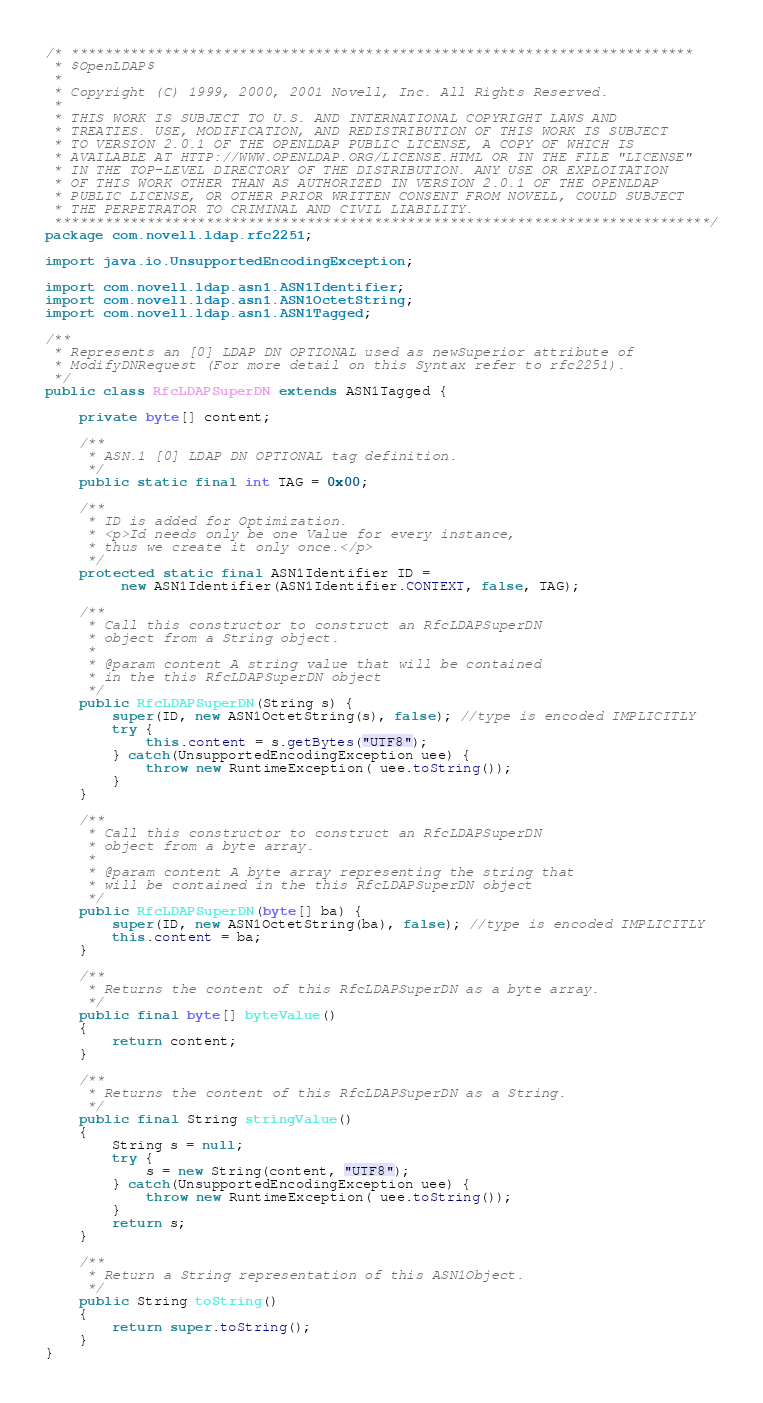<code> <loc_0><loc_0><loc_500><loc_500><_Java_>/* **************************************************************************
 * $OpenLDAP$
 *
 * Copyright (C) 1999, 2000, 2001 Novell, Inc. All Rights Reserved.
 *
 * THIS WORK IS SUBJECT TO U.S. AND INTERNATIONAL COPYRIGHT LAWS AND
 * TREATIES. USE, MODIFICATION, AND REDISTRIBUTION OF THIS WORK IS SUBJECT
 * TO VERSION 2.0.1 OF THE OPENLDAP PUBLIC LICENSE, A COPY OF WHICH IS
 * AVAILABLE AT HTTP://WWW.OPENLDAP.ORG/LICENSE.HTML OR IN THE FILE "LICENSE"
 * IN THE TOP-LEVEL DIRECTORY OF THE DISTRIBUTION. ANY USE OR EXPLOITATION
 * OF THIS WORK OTHER THAN AS AUTHORIZED IN VERSION 2.0.1 OF THE OPENLDAP
 * PUBLIC LICENSE, OR OTHER PRIOR WRITTEN CONSENT FROM NOVELL, COULD SUBJECT
 * THE PERPETRATOR TO CRIMINAL AND CIVIL LIABILITY.
 ******************************************************************************/
package com.novell.ldap.rfc2251;

import java.io.UnsupportedEncodingException;

import com.novell.ldap.asn1.ASN1Identifier;
import com.novell.ldap.asn1.ASN1OctetString;
import com.novell.ldap.asn1.ASN1Tagged;

/**
 * Represents an [0] LDAP DN OPTIONAL used as newSuperior attribute of
 * ModifyDNRequest (For more detail on this Syntax refer to rfc2251).
 */
public class RfcLDAPSuperDN extends ASN1Tagged {

	private byte[] content;
	
	/**
     * ASN.1 [0] LDAP DN OPTIONAL tag definition.
     */
    public static final int TAG = 0x00;

    /**
     * ID is added for Optimization.
     * <p>Id needs only be one Value for every instance,
     * thus we create it only once.</p>
     */
    protected static final ASN1Identifier ID =
         new ASN1Identifier(ASN1Identifier.CONTEXT, false, TAG);
   
    /**
     * Call this constructor to construct an RfcLDAPSuperDN
     * object from a String object.
     *
     * @param content A string value that will be contained
     * in the this RfcLDAPSuperDN object
     */
	public RfcLDAPSuperDN(String s) {
		super(ID, new ASN1OctetString(s), false); //type is encoded IMPLICITLY
		try {
            this.content = s.getBytes("UTF8");
        } catch(UnsupportedEncodingException uee) {
            throw new RuntimeException( uee.toString());
        }
	}

	/**
     * Call this constructor to construct an RfcLDAPSuperDN
     * object from a byte array.
     *
     * @param content A byte array representing the string that
     * will be contained in the this RfcLDAPSuperDN object
     */
	public RfcLDAPSuperDN(byte[] ba) {
		super(ID, new ASN1OctetString(ba), false); //type is encoded IMPLICITLY 
		this.content = ba;
	}
	
	/**
     * Returns the content of this RfcLDAPSuperDN as a byte array.
     */
    public final byte[] byteValue()
    {
        return content;
    }

    /**
     * Returns the content of this RfcLDAPSuperDN as a String.
     */
    public final String stringValue()
    {
        String s = null;
        try {
            s = new String(content, "UTF8");
        } catch(UnsupportedEncodingException uee) {
            throw new RuntimeException( uee.toString());
        }
        return s;
    }

    /**
     * Return a String representation of this ASN1Object.
     */
    public String toString()
    {
      	return super.toString();
    }
}
</code> 